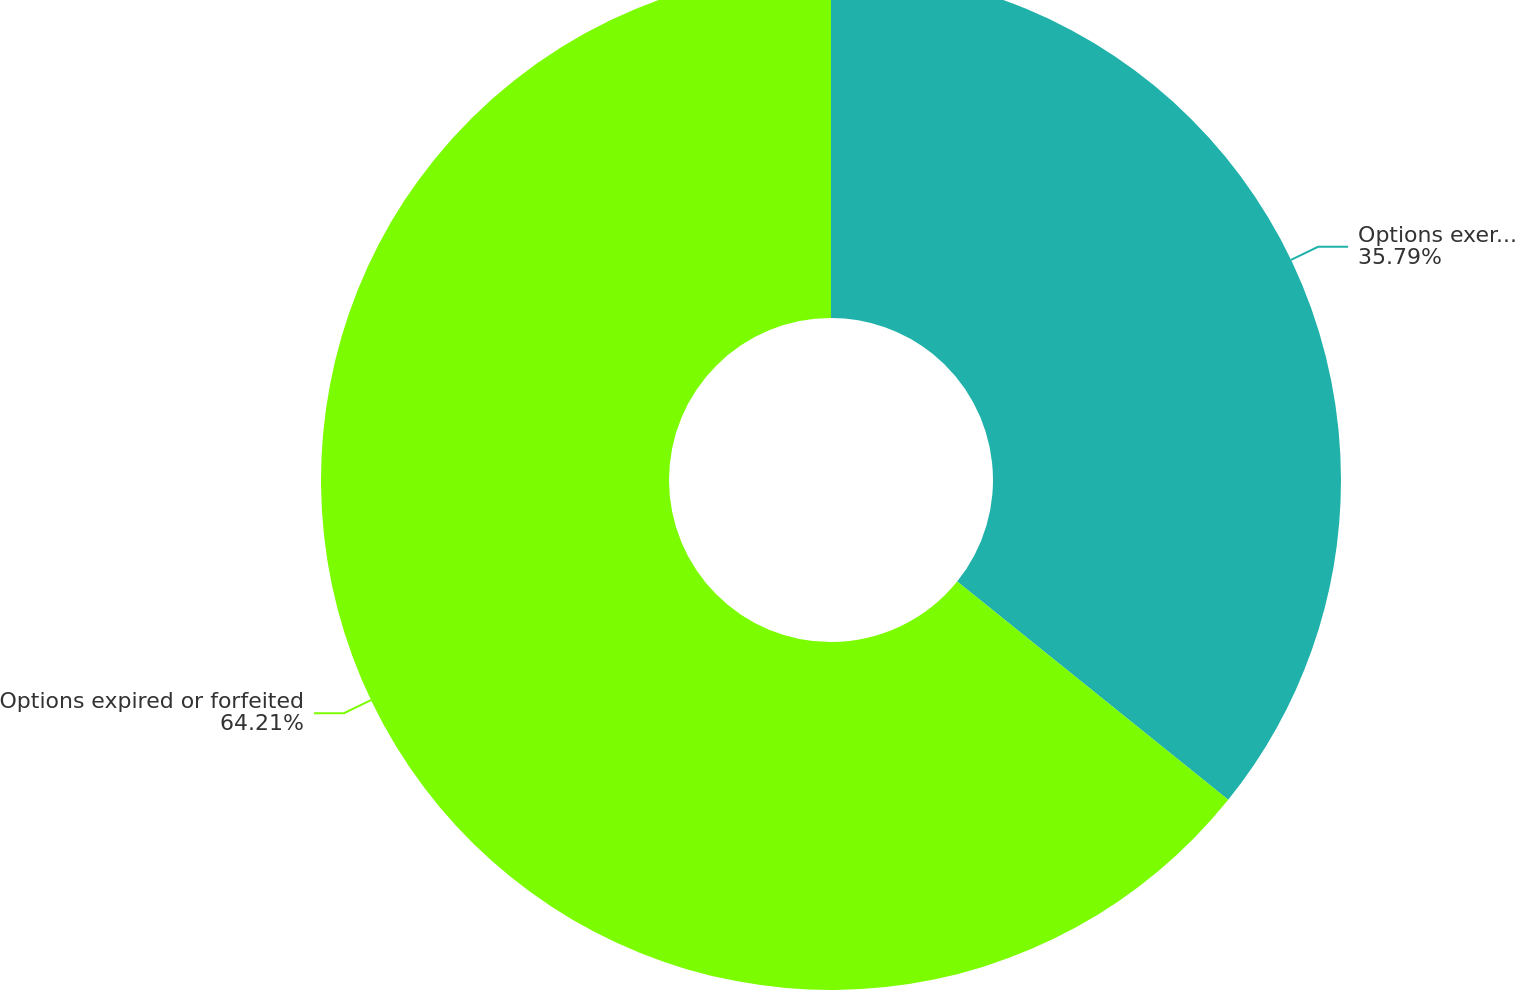Convert chart. <chart><loc_0><loc_0><loc_500><loc_500><pie_chart><fcel>Options exercised<fcel>Options expired or forfeited<nl><fcel>35.79%<fcel>64.21%<nl></chart> 